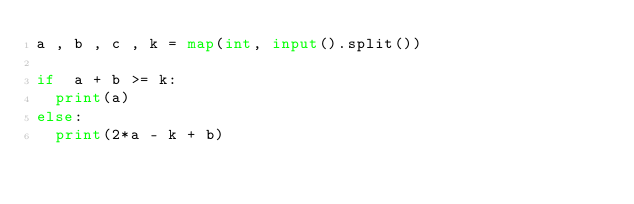<code> <loc_0><loc_0><loc_500><loc_500><_Python_>a , b , c , k = map(int, input().split())

if  a + b >= k:
  print(a)
else:
  print(2*a - k + b)

</code> 